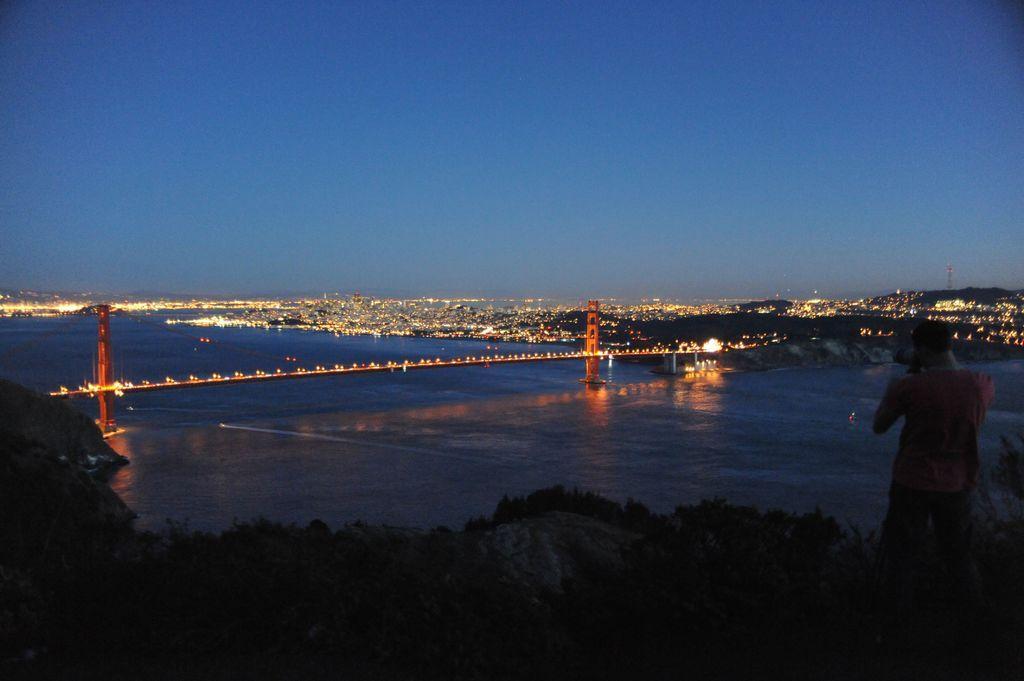Could you give a brief overview of what you see in this image? In this image, we can see a person standing on the hill and in the background, there is a bridge and we can see lights and there is water. At the top, there is sky. 